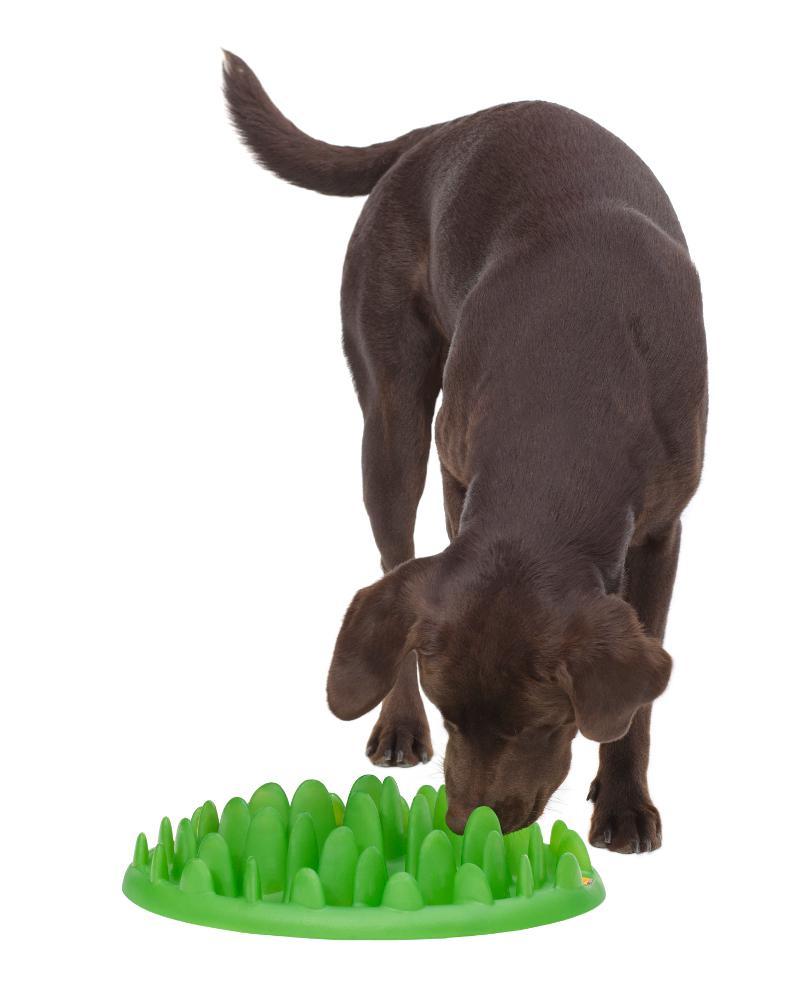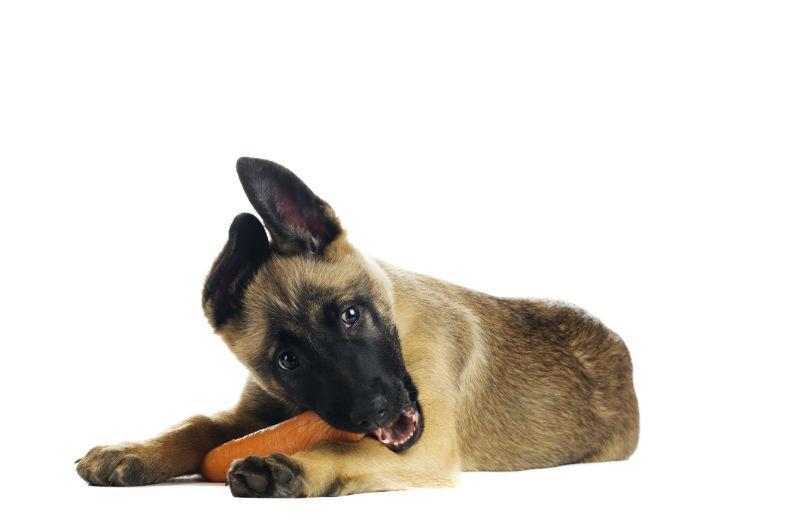The first image is the image on the left, the second image is the image on the right. For the images displayed, is the sentence "One dog is eating and has its head near a round bowl of food, and the other dog figure is standing on all fours." factually correct? Answer yes or no. No. 